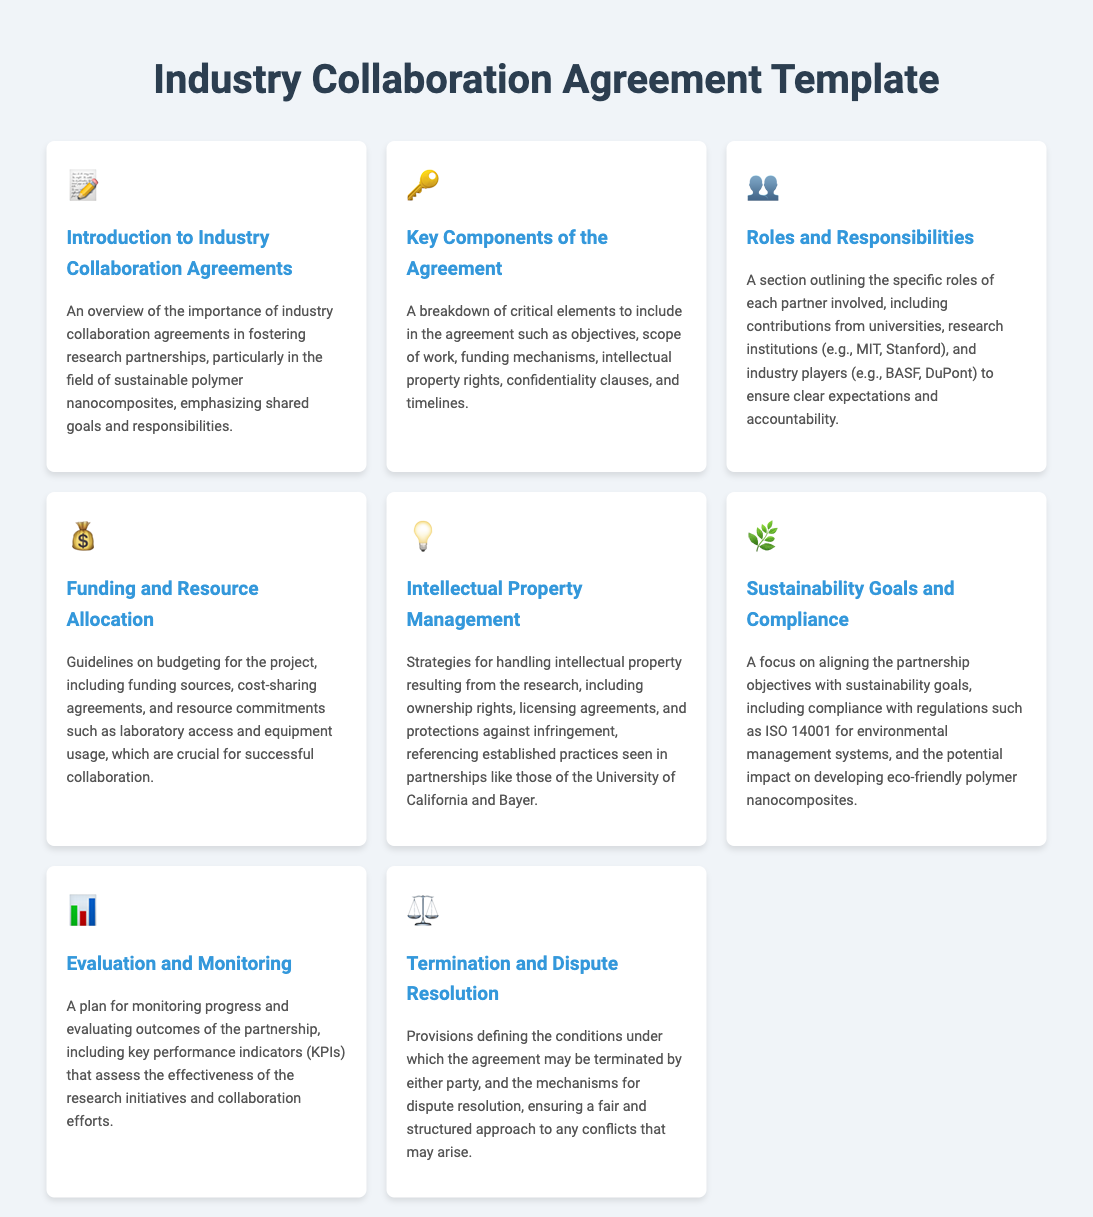What is the title of the document? The title is specified in the head section of the HTML document.
Answer: Industry Collaboration Agreement Template What is the main purpose of industry collaboration agreements? The purpose is outlined in the introduction section of the document.
Answer: Fostering research partnerships Which section addresses the roles of each partner? This can be found in the specific menu item that discusses partner contributions and expectations.
Answer: Roles and Responsibilities What is one key component to include in the agreement? This is mentioned in the key components section.
Answer: Intellectual property rights What sustainability standard is mentioned? The standard is indicated in the sustainability goals section of the document.
Answer: ISO 14001 What aspect is evaluated according to the evaluation and monitoring section? This pertains to the methods of assessing research initiatives.
Answer: Key performance indicators What is outlined in the termination and dispute resolution section? The section specifies the conditions and procedures related to disputes.
Answer: Mechanisms for dispute resolution Which entity is referenced as a partner in intellectual property management? The document mentions an academic partner in relation to IP management.
Answer: University of California What type of funding agreements are discussed? This detail is provided in the funding and resource allocation section.
Answer: Cost-sharing agreements 